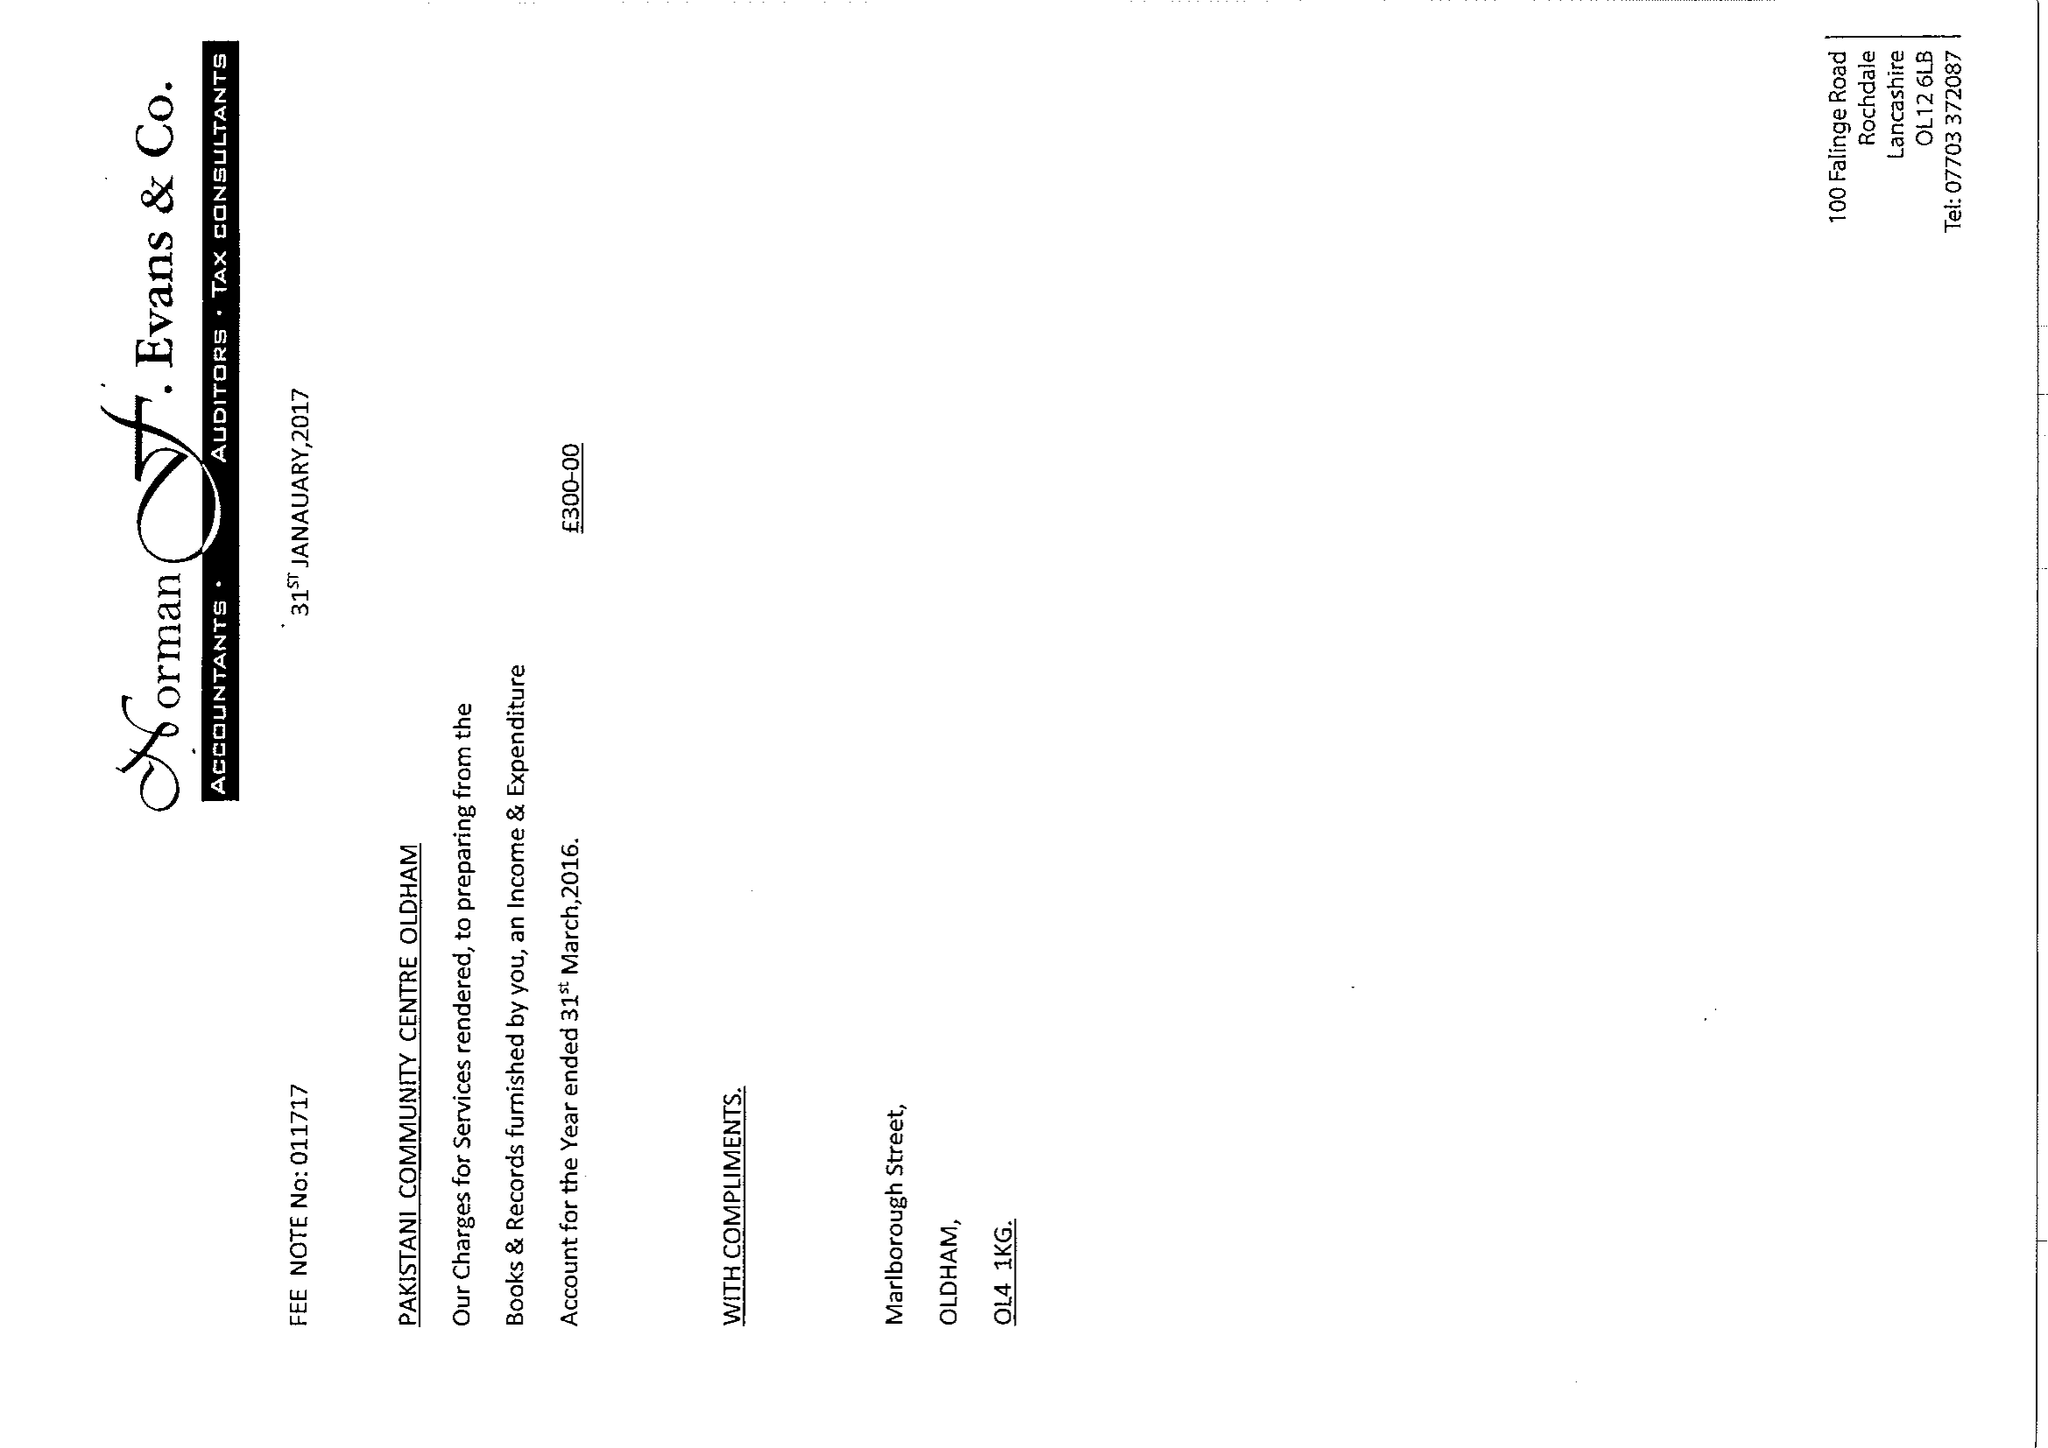What is the value for the address__postcode?
Answer the question using a single word or phrase. OL4 1EG 